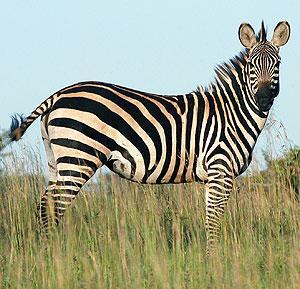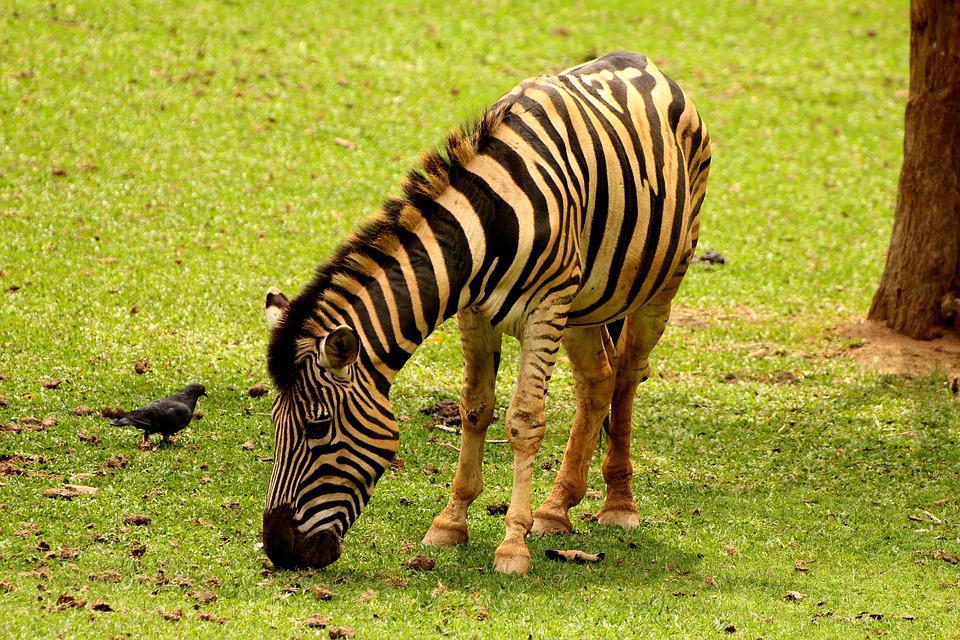The first image is the image on the left, the second image is the image on the right. Assess this claim about the two images: "A zebra has its head down eating the very short green grass.". Correct or not? Answer yes or no. Yes. The first image is the image on the left, the second image is the image on the right. For the images shown, is this caption "In one image a lone zebra is standing and grazing in the grass." true? Answer yes or no. Yes. 